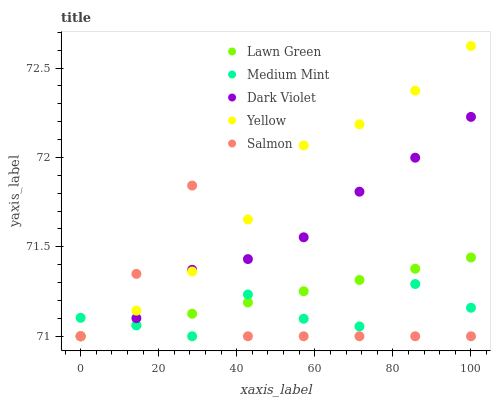Does Medium Mint have the minimum area under the curve?
Answer yes or no. Yes. Does Yellow have the maximum area under the curve?
Answer yes or no. Yes. Does Lawn Green have the minimum area under the curve?
Answer yes or no. No. Does Lawn Green have the maximum area under the curve?
Answer yes or no. No. Is Lawn Green the smoothest?
Answer yes or no. Yes. Is Salmon the roughest?
Answer yes or no. Yes. Is Salmon the smoothest?
Answer yes or no. No. Is Lawn Green the roughest?
Answer yes or no. No. Does Medium Mint have the lowest value?
Answer yes or no. Yes. Does Yellow have the highest value?
Answer yes or no. Yes. Does Lawn Green have the highest value?
Answer yes or no. No. Does Dark Violet intersect Lawn Green?
Answer yes or no. Yes. Is Dark Violet less than Lawn Green?
Answer yes or no. No. Is Dark Violet greater than Lawn Green?
Answer yes or no. No. 